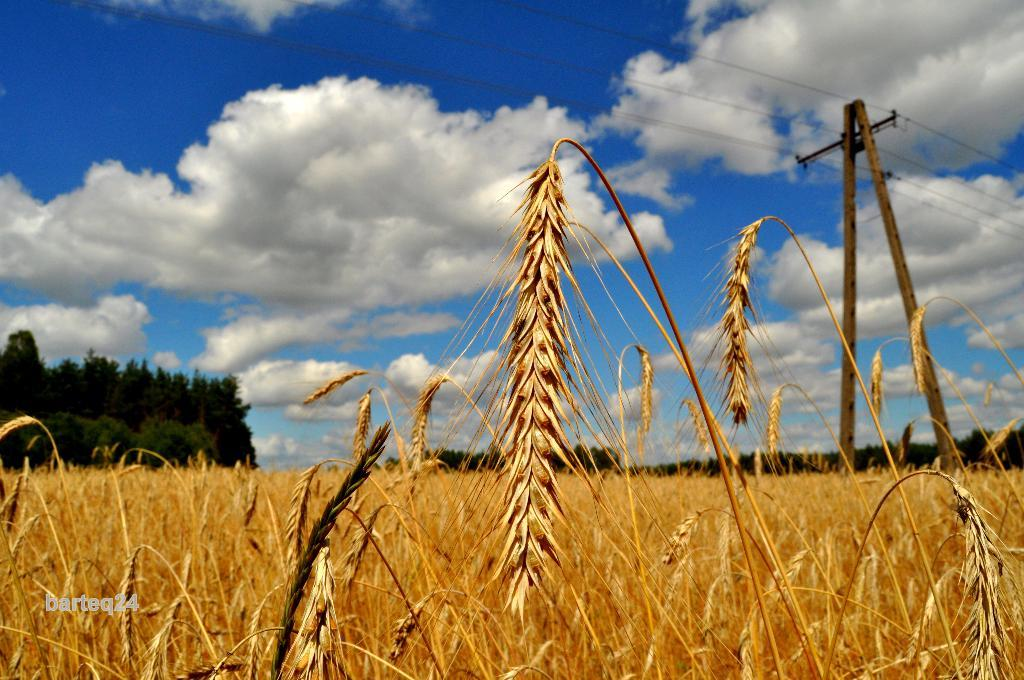What type of vegetation is in the front of the image? There is dry grass in the front of the image. What can be seen in the background of the image? There are trees and a pole in the background of the image. What is on the pole in the background of the image? There are wires on the pole in the background of the image. How would you describe the sky in the image? The sky is cloudy in the image. What type of wax is being used to create the fifth tree in the image? There is no wax or fifth tree present in the image. How does the earthquake affect the pole and wires in the image? There is no earthquake present in the image, so its effects cannot be observed. 